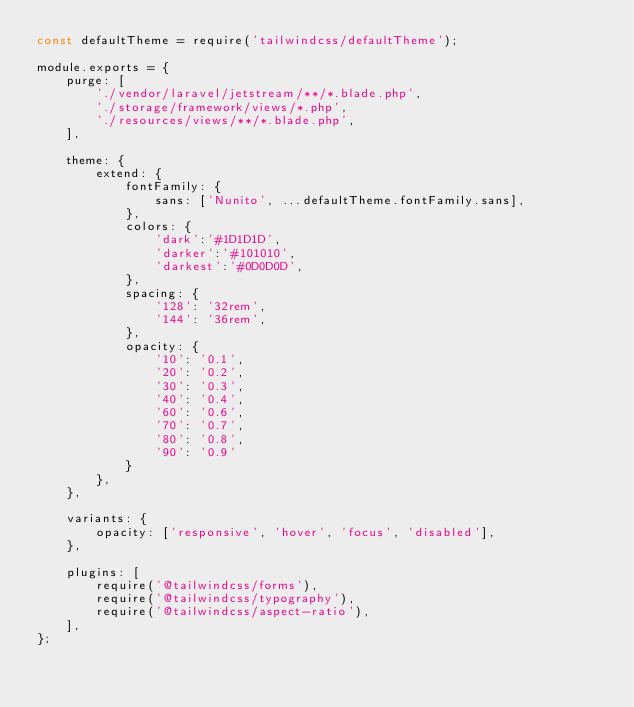<code> <loc_0><loc_0><loc_500><loc_500><_JavaScript_>const defaultTheme = require('tailwindcss/defaultTheme');

module.exports = {
    purge: [
        './vendor/laravel/jetstream/**/*.blade.php',
        './storage/framework/views/*.php',
        './resources/views/**/*.blade.php',
    ],

    theme: {
        extend: {
            fontFamily: {
                sans: ['Nunito', ...defaultTheme.fontFamily.sans],
            },
            colors: {
                'dark':'#1D1D1D',
                'darker':'#101010',
                'darkest':'#0D0D0D',
            },
            spacing: {
                '128': '32rem',
                '144': '36rem',
            },
            opacity: {
                '10': '0.1',
                '20': '0.2',
                '30': '0.3',
                '40': '0.4',
                '60': '0.6',
                '70': '0.7',
                '80': '0.8',
                '90': '0.9'
            }
        },
    },

    variants: {
        opacity: ['responsive', 'hover', 'focus', 'disabled'],
    },

    plugins: [
        require('@tailwindcss/forms'),
        require('@tailwindcss/typography'),
        require('@tailwindcss/aspect-ratio'),
    ],
};
</code> 